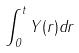<formula> <loc_0><loc_0><loc_500><loc_500>\int _ { 0 } ^ { t } Y ( r ) d r</formula> 